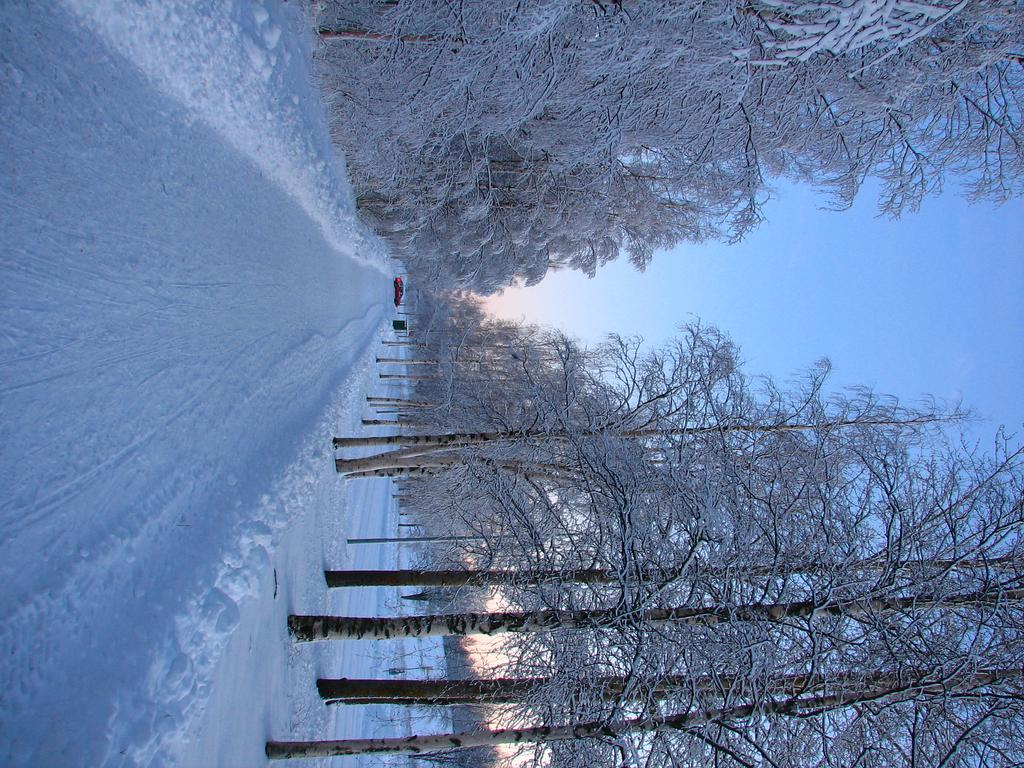What type of vegetation can be seen in the image? There are trees in the image. What is located on the snow in the image? There is a vehicle on the snow in the image. What is visible in the background of the image? The sky is visible in the image. Can you tell me how much zinc is present in the lake shown in the image? There is no lake present in the image, and therefore no zinc can be measured. What type of pump is visible in the image? There is no pump present in the image. 